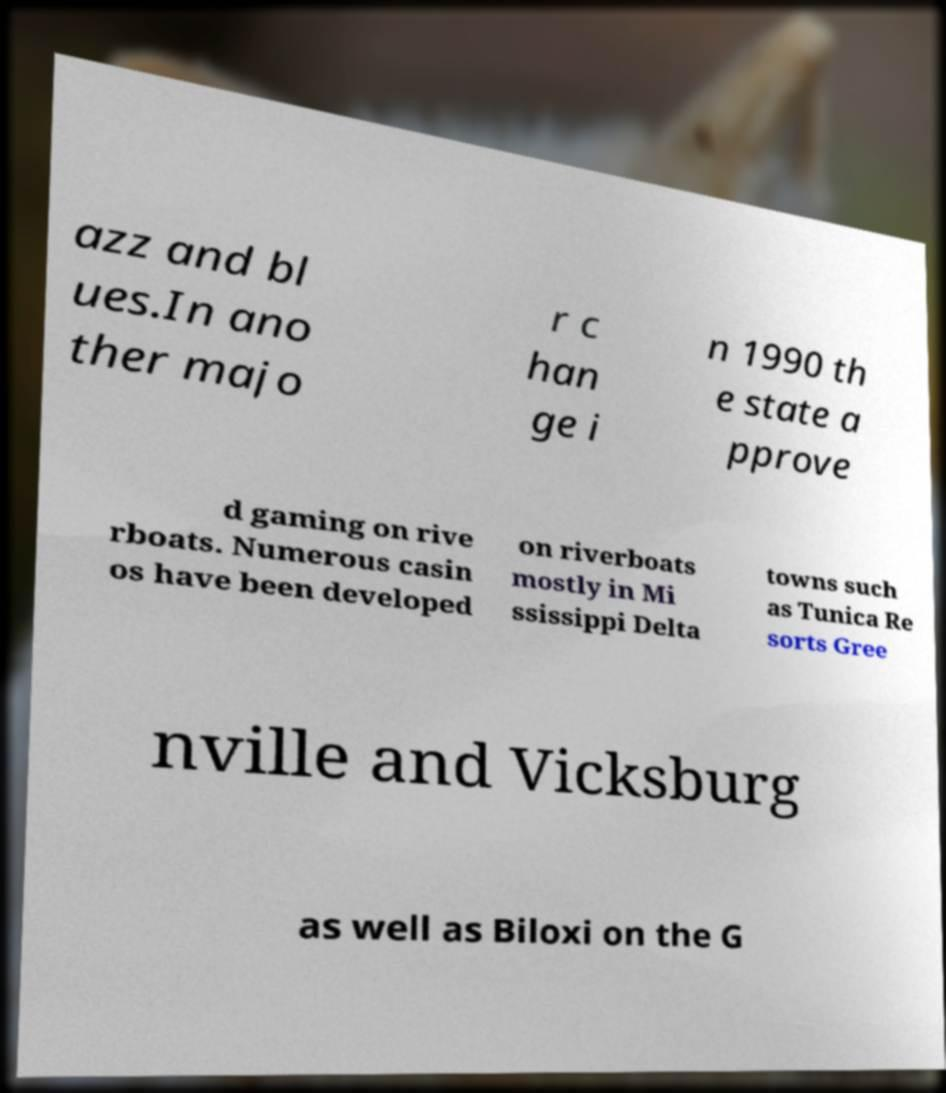Can you read and provide the text displayed in the image?This photo seems to have some interesting text. Can you extract and type it out for me? azz and bl ues.In ano ther majo r c han ge i n 1990 th e state a pprove d gaming on rive rboats. Numerous casin os have been developed on riverboats mostly in Mi ssissippi Delta towns such as Tunica Re sorts Gree nville and Vicksburg as well as Biloxi on the G 